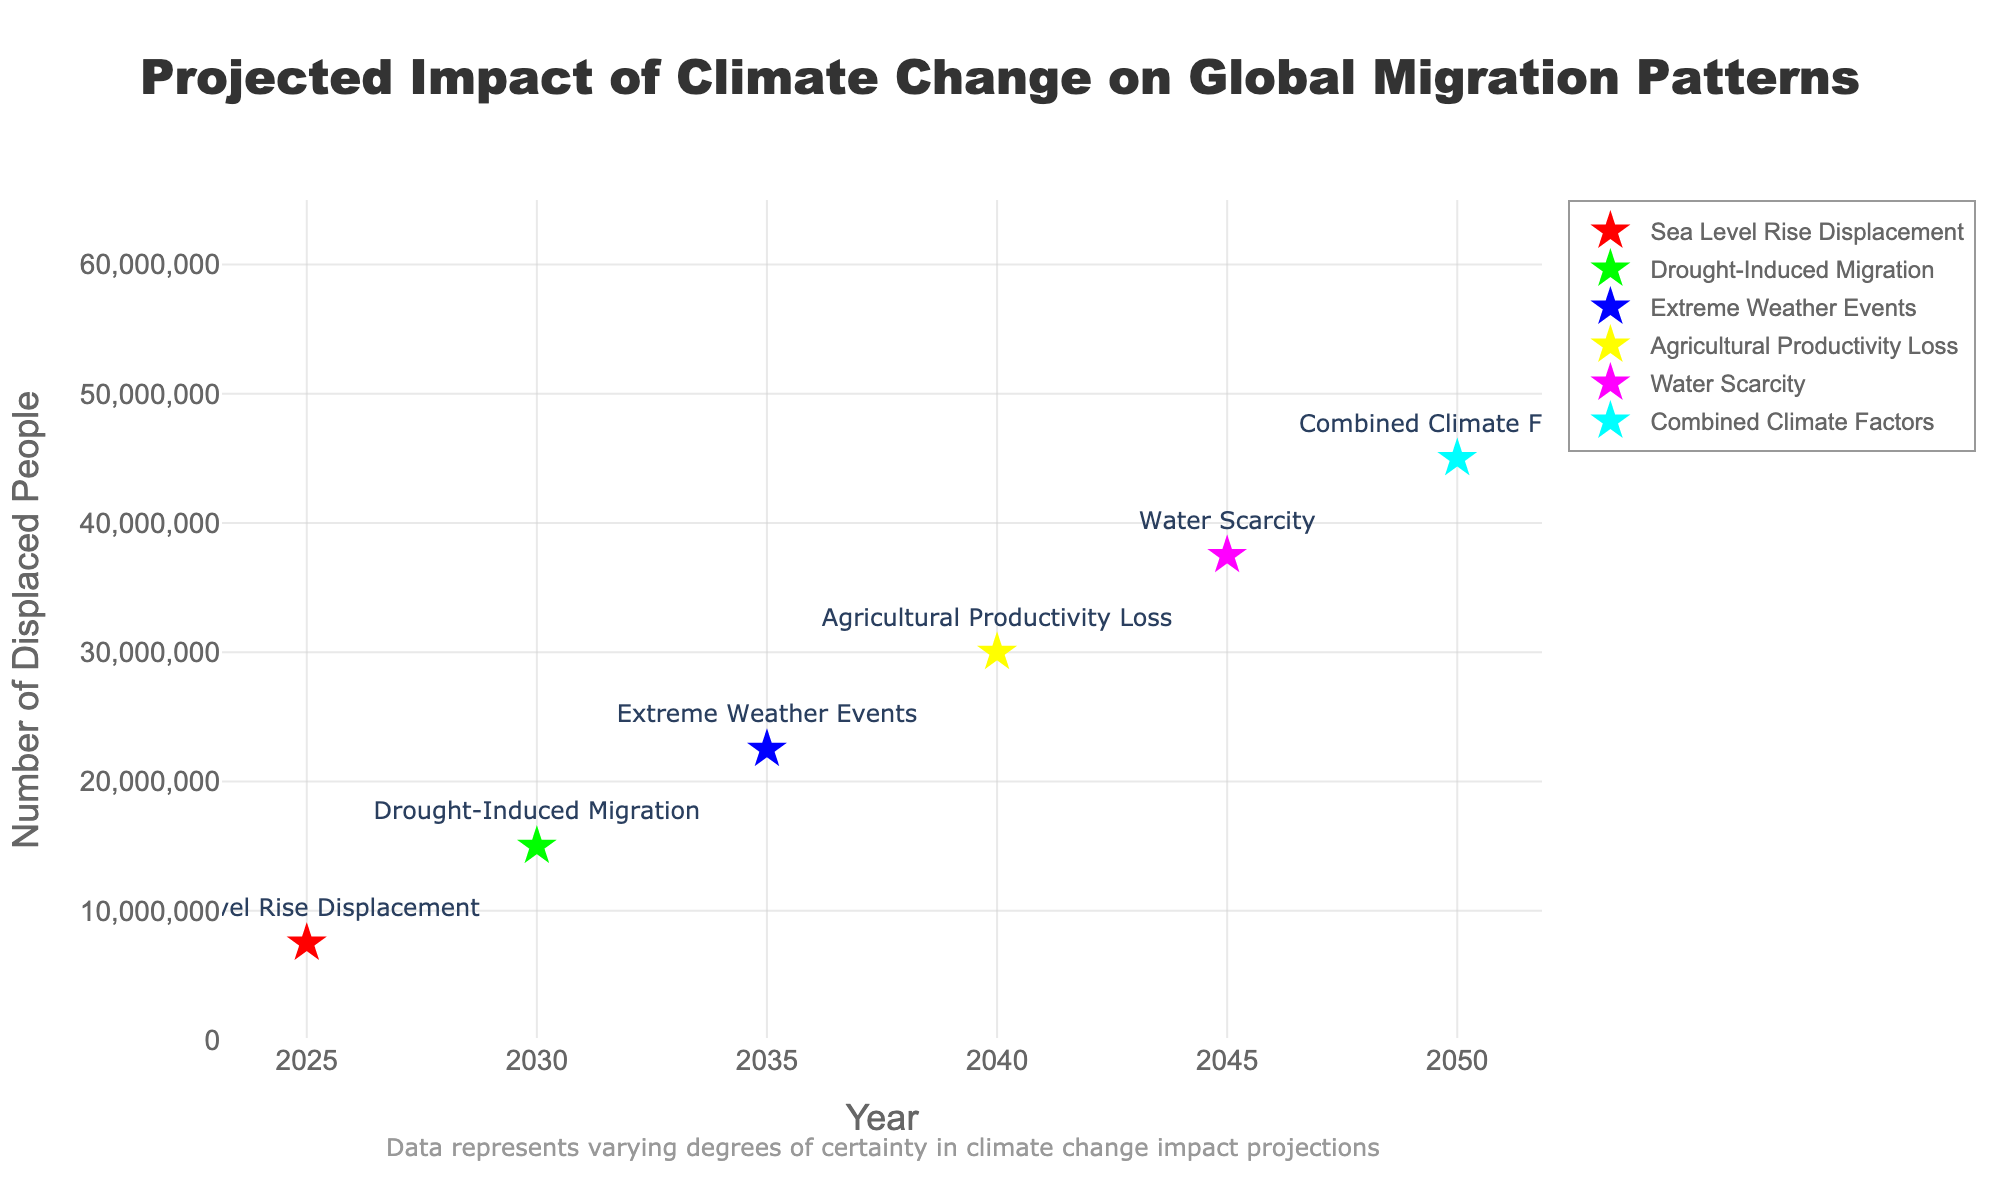how many migration scenarios are depicted in this chart? The title and legend of the figure indicate distinct scenarios for climate-change-related migration. Counting each scenario mentioned in the legend or listed in the plots provides the total number of scenarios.
Answer: 6 What migration scenario has the highest medium estimate by 2050? From the chart, we can see the medium estimates for each scenario marked with a star symbol. The highest medium estimate is associated with the scenario "Combined Climate Factors" in 2050, as indicated by the label and numerical value.
Answer: Combined Climate Factors What is the range of projected displacements for Drought-Induced Migration in 2030? Refer to the values for 2030 and the Drought-Induced Migration scenario. The low estimate is 10,000,000 and the high estimate is 20,000,000. The range is these two values.
Answer: 10,000,000 to 20,000,000 Which scenario appears to be the most uncertain based on the difference between its high and low estimates? By comparing the differences between the high and low estimates for each scenario, the scenario with the largest difference indicates the most uncertainty. "Water Scarcity" in 2045 shows the highest difference (25,000,000).
Answer: Water Scarcity What is the combined medium estimate of displaced people for the scenarios in 2035 and 2040? First, identify the medium estimates for 2035 and 2040: 22,500,000 and 30,000,000. Sum these values directly.
Answer: 52,500,000 How much does the medium estimate increase from 2025 to 2050 under the presented scenarios? Locate the medium estimates for the years 2025 and 2050: 7,500,000 and 45,000,000. Subtract 7,500,000 from 45,000,000 to find the increase.
Answer: 37,500,000 What is the trend observed in medium estimates from 2025 to 2050? By observing the medium estimates for each scenario from 2025 to 2050, it's evident that the values generally increase, indicating a rising trend in projected displacements.
Answer: Increasing trend How does the projected impact of agricultural productivity loss in 2040 compare to water scarcity in 2045? Compare the medium estimates for 2040 (agricultural productivity loss) which is 30,000,000, and 2045 (water scarcity) which is 37,500,000. The 2045 estimate is higher.
Answer: Water scarcity is higher Which scenario's projection shows the lowest increase in displacement from one decade to the next? Evaluate the decade-to-decade increases for each scenario. "Sea Level Rise Displacement" shows the smallest increase from 2025 to 2035 (from 7.5M to 15M), largest increase is for Water Scarcity. The values are closely compared for better analysis.
Answer: Sea Level Rise Displacement 